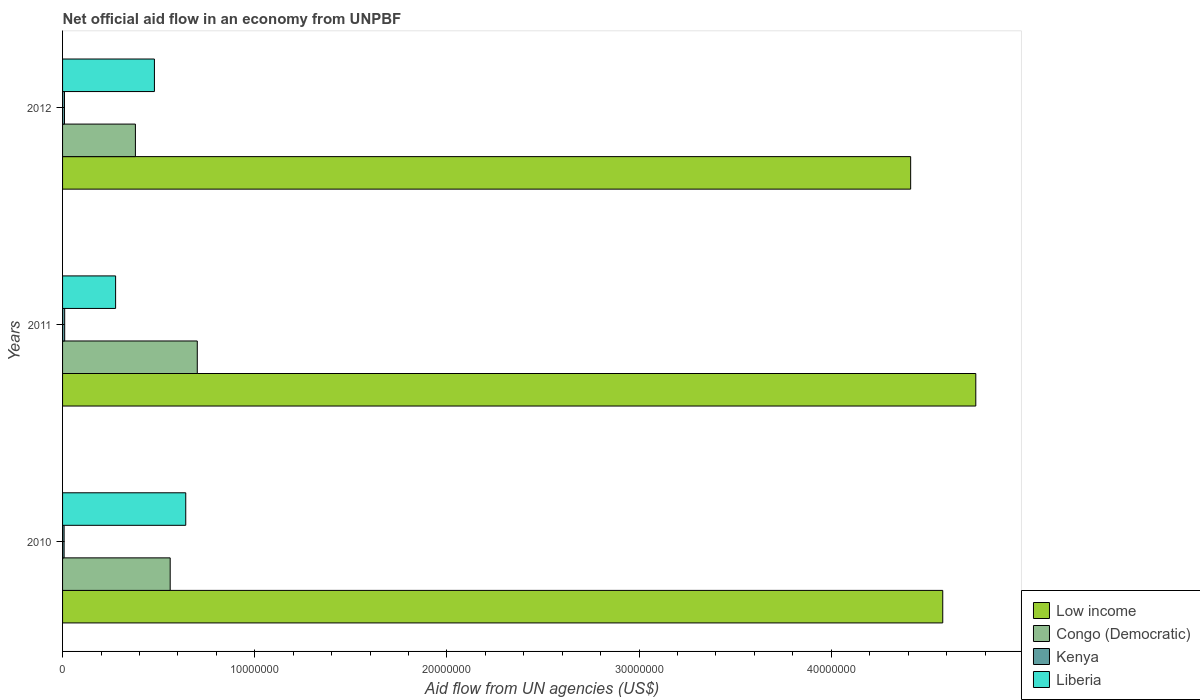How many groups of bars are there?
Offer a very short reply. 3. Are the number of bars per tick equal to the number of legend labels?
Keep it short and to the point. Yes. How many bars are there on the 1st tick from the top?
Offer a very short reply. 4. How many bars are there on the 1st tick from the bottom?
Give a very brief answer. 4. In how many cases, is the number of bars for a given year not equal to the number of legend labels?
Make the answer very short. 0. What is the net official aid flow in Kenya in 2010?
Make the answer very short. 8.00e+04. Across all years, what is the maximum net official aid flow in Congo (Democratic)?
Make the answer very short. 7.01e+06. Across all years, what is the minimum net official aid flow in Liberia?
Keep it short and to the point. 2.76e+06. In which year was the net official aid flow in Kenya maximum?
Your response must be concise. 2011. What is the total net official aid flow in Low income in the graph?
Make the answer very short. 1.37e+08. What is the difference between the net official aid flow in Liberia in 2011 and the net official aid flow in Congo (Democratic) in 2012?
Offer a terse response. -1.03e+06. What is the average net official aid flow in Kenya per year?
Your response must be concise. 9.67e+04. In the year 2010, what is the difference between the net official aid flow in Low income and net official aid flow in Congo (Democratic)?
Give a very brief answer. 4.02e+07. What is the ratio of the net official aid flow in Low income in 2011 to that in 2012?
Your response must be concise. 1.08. Is the difference between the net official aid flow in Low income in 2011 and 2012 greater than the difference between the net official aid flow in Congo (Democratic) in 2011 and 2012?
Ensure brevity in your answer.  Yes. What is the difference between the highest and the second highest net official aid flow in Low income?
Your answer should be compact. 1.72e+06. What is the difference between the highest and the lowest net official aid flow in Liberia?
Ensure brevity in your answer.  3.65e+06. In how many years, is the net official aid flow in Low income greater than the average net official aid flow in Low income taken over all years?
Provide a succinct answer. 1. Is it the case that in every year, the sum of the net official aid flow in Congo (Democratic) and net official aid flow in Liberia is greater than the sum of net official aid flow in Kenya and net official aid flow in Low income?
Your answer should be very brief. No. What does the 2nd bar from the top in 2010 represents?
Make the answer very short. Kenya. Are all the bars in the graph horizontal?
Provide a short and direct response. Yes. How many years are there in the graph?
Give a very brief answer. 3. What is the difference between two consecutive major ticks on the X-axis?
Make the answer very short. 1.00e+07. Are the values on the major ticks of X-axis written in scientific E-notation?
Give a very brief answer. No. Where does the legend appear in the graph?
Offer a very short reply. Bottom right. What is the title of the graph?
Give a very brief answer. Net official aid flow in an economy from UNPBF. Does "Russian Federation" appear as one of the legend labels in the graph?
Your answer should be compact. No. What is the label or title of the X-axis?
Your answer should be compact. Aid flow from UN agencies (US$). What is the label or title of the Y-axis?
Offer a terse response. Years. What is the Aid flow from UN agencies (US$) in Low income in 2010?
Provide a succinct answer. 4.58e+07. What is the Aid flow from UN agencies (US$) of Congo (Democratic) in 2010?
Your answer should be very brief. 5.60e+06. What is the Aid flow from UN agencies (US$) in Liberia in 2010?
Provide a succinct answer. 6.41e+06. What is the Aid flow from UN agencies (US$) of Low income in 2011?
Keep it short and to the point. 4.75e+07. What is the Aid flow from UN agencies (US$) in Congo (Democratic) in 2011?
Ensure brevity in your answer.  7.01e+06. What is the Aid flow from UN agencies (US$) of Kenya in 2011?
Keep it short and to the point. 1.10e+05. What is the Aid flow from UN agencies (US$) of Liberia in 2011?
Your answer should be very brief. 2.76e+06. What is the Aid flow from UN agencies (US$) in Low income in 2012?
Ensure brevity in your answer.  4.41e+07. What is the Aid flow from UN agencies (US$) in Congo (Democratic) in 2012?
Offer a terse response. 3.79e+06. What is the Aid flow from UN agencies (US$) of Liberia in 2012?
Offer a terse response. 4.78e+06. Across all years, what is the maximum Aid flow from UN agencies (US$) in Low income?
Provide a short and direct response. 4.75e+07. Across all years, what is the maximum Aid flow from UN agencies (US$) of Congo (Democratic)?
Give a very brief answer. 7.01e+06. Across all years, what is the maximum Aid flow from UN agencies (US$) of Liberia?
Your answer should be very brief. 6.41e+06. Across all years, what is the minimum Aid flow from UN agencies (US$) of Low income?
Your response must be concise. 4.41e+07. Across all years, what is the minimum Aid flow from UN agencies (US$) in Congo (Democratic)?
Provide a short and direct response. 3.79e+06. Across all years, what is the minimum Aid flow from UN agencies (US$) in Liberia?
Provide a succinct answer. 2.76e+06. What is the total Aid flow from UN agencies (US$) of Low income in the graph?
Your answer should be compact. 1.37e+08. What is the total Aid flow from UN agencies (US$) in Congo (Democratic) in the graph?
Provide a short and direct response. 1.64e+07. What is the total Aid flow from UN agencies (US$) of Kenya in the graph?
Your response must be concise. 2.90e+05. What is the total Aid flow from UN agencies (US$) in Liberia in the graph?
Keep it short and to the point. 1.40e+07. What is the difference between the Aid flow from UN agencies (US$) in Low income in 2010 and that in 2011?
Offer a very short reply. -1.72e+06. What is the difference between the Aid flow from UN agencies (US$) in Congo (Democratic) in 2010 and that in 2011?
Provide a short and direct response. -1.41e+06. What is the difference between the Aid flow from UN agencies (US$) in Kenya in 2010 and that in 2011?
Make the answer very short. -3.00e+04. What is the difference between the Aid flow from UN agencies (US$) in Liberia in 2010 and that in 2011?
Offer a terse response. 3.65e+06. What is the difference between the Aid flow from UN agencies (US$) in Low income in 2010 and that in 2012?
Your answer should be compact. 1.67e+06. What is the difference between the Aid flow from UN agencies (US$) in Congo (Democratic) in 2010 and that in 2012?
Keep it short and to the point. 1.81e+06. What is the difference between the Aid flow from UN agencies (US$) in Kenya in 2010 and that in 2012?
Provide a short and direct response. -2.00e+04. What is the difference between the Aid flow from UN agencies (US$) in Liberia in 2010 and that in 2012?
Your answer should be very brief. 1.63e+06. What is the difference between the Aid flow from UN agencies (US$) in Low income in 2011 and that in 2012?
Give a very brief answer. 3.39e+06. What is the difference between the Aid flow from UN agencies (US$) in Congo (Democratic) in 2011 and that in 2012?
Give a very brief answer. 3.22e+06. What is the difference between the Aid flow from UN agencies (US$) of Kenya in 2011 and that in 2012?
Ensure brevity in your answer.  10000. What is the difference between the Aid flow from UN agencies (US$) of Liberia in 2011 and that in 2012?
Your answer should be compact. -2.02e+06. What is the difference between the Aid flow from UN agencies (US$) in Low income in 2010 and the Aid flow from UN agencies (US$) in Congo (Democratic) in 2011?
Keep it short and to the point. 3.88e+07. What is the difference between the Aid flow from UN agencies (US$) in Low income in 2010 and the Aid flow from UN agencies (US$) in Kenya in 2011?
Provide a succinct answer. 4.57e+07. What is the difference between the Aid flow from UN agencies (US$) of Low income in 2010 and the Aid flow from UN agencies (US$) of Liberia in 2011?
Offer a terse response. 4.30e+07. What is the difference between the Aid flow from UN agencies (US$) in Congo (Democratic) in 2010 and the Aid flow from UN agencies (US$) in Kenya in 2011?
Your answer should be compact. 5.49e+06. What is the difference between the Aid flow from UN agencies (US$) in Congo (Democratic) in 2010 and the Aid flow from UN agencies (US$) in Liberia in 2011?
Ensure brevity in your answer.  2.84e+06. What is the difference between the Aid flow from UN agencies (US$) in Kenya in 2010 and the Aid flow from UN agencies (US$) in Liberia in 2011?
Your answer should be very brief. -2.68e+06. What is the difference between the Aid flow from UN agencies (US$) in Low income in 2010 and the Aid flow from UN agencies (US$) in Congo (Democratic) in 2012?
Provide a succinct answer. 4.20e+07. What is the difference between the Aid flow from UN agencies (US$) in Low income in 2010 and the Aid flow from UN agencies (US$) in Kenya in 2012?
Keep it short and to the point. 4.57e+07. What is the difference between the Aid flow from UN agencies (US$) of Low income in 2010 and the Aid flow from UN agencies (US$) of Liberia in 2012?
Your answer should be very brief. 4.10e+07. What is the difference between the Aid flow from UN agencies (US$) of Congo (Democratic) in 2010 and the Aid flow from UN agencies (US$) of Kenya in 2012?
Your answer should be compact. 5.50e+06. What is the difference between the Aid flow from UN agencies (US$) of Congo (Democratic) in 2010 and the Aid flow from UN agencies (US$) of Liberia in 2012?
Offer a very short reply. 8.20e+05. What is the difference between the Aid flow from UN agencies (US$) of Kenya in 2010 and the Aid flow from UN agencies (US$) of Liberia in 2012?
Give a very brief answer. -4.70e+06. What is the difference between the Aid flow from UN agencies (US$) of Low income in 2011 and the Aid flow from UN agencies (US$) of Congo (Democratic) in 2012?
Your answer should be compact. 4.37e+07. What is the difference between the Aid flow from UN agencies (US$) in Low income in 2011 and the Aid flow from UN agencies (US$) in Kenya in 2012?
Provide a short and direct response. 4.74e+07. What is the difference between the Aid flow from UN agencies (US$) in Low income in 2011 and the Aid flow from UN agencies (US$) in Liberia in 2012?
Provide a short and direct response. 4.27e+07. What is the difference between the Aid flow from UN agencies (US$) in Congo (Democratic) in 2011 and the Aid flow from UN agencies (US$) in Kenya in 2012?
Provide a succinct answer. 6.91e+06. What is the difference between the Aid flow from UN agencies (US$) of Congo (Democratic) in 2011 and the Aid flow from UN agencies (US$) of Liberia in 2012?
Your answer should be compact. 2.23e+06. What is the difference between the Aid flow from UN agencies (US$) in Kenya in 2011 and the Aid flow from UN agencies (US$) in Liberia in 2012?
Offer a very short reply. -4.67e+06. What is the average Aid flow from UN agencies (US$) in Low income per year?
Your response must be concise. 4.58e+07. What is the average Aid flow from UN agencies (US$) in Congo (Democratic) per year?
Provide a succinct answer. 5.47e+06. What is the average Aid flow from UN agencies (US$) in Kenya per year?
Make the answer very short. 9.67e+04. What is the average Aid flow from UN agencies (US$) in Liberia per year?
Provide a short and direct response. 4.65e+06. In the year 2010, what is the difference between the Aid flow from UN agencies (US$) of Low income and Aid flow from UN agencies (US$) of Congo (Democratic)?
Offer a very short reply. 4.02e+07. In the year 2010, what is the difference between the Aid flow from UN agencies (US$) in Low income and Aid flow from UN agencies (US$) in Kenya?
Make the answer very short. 4.57e+07. In the year 2010, what is the difference between the Aid flow from UN agencies (US$) of Low income and Aid flow from UN agencies (US$) of Liberia?
Provide a short and direct response. 3.94e+07. In the year 2010, what is the difference between the Aid flow from UN agencies (US$) in Congo (Democratic) and Aid flow from UN agencies (US$) in Kenya?
Make the answer very short. 5.52e+06. In the year 2010, what is the difference between the Aid flow from UN agencies (US$) in Congo (Democratic) and Aid flow from UN agencies (US$) in Liberia?
Your answer should be compact. -8.10e+05. In the year 2010, what is the difference between the Aid flow from UN agencies (US$) in Kenya and Aid flow from UN agencies (US$) in Liberia?
Your answer should be compact. -6.33e+06. In the year 2011, what is the difference between the Aid flow from UN agencies (US$) of Low income and Aid flow from UN agencies (US$) of Congo (Democratic)?
Your response must be concise. 4.05e+07. In the year 2011, what is the difference between the Aid flow from UN agencies (US$) in Low income and Aid flow from UN agencies (US$) in Kenya?
Offer a terse response. 4.74e+07. In the year 2011, what is the difference between the Aid flow from UN agencies (US$) of Low income and Aid flow from UN agencies (US$) of Liberia?
Provide a short and direct response. 4.48e+07. In the year 2011, what is the difference between the Aid flow from UN agencies (US$) of Congo (Democratic) and Aid flow from UN agencies (US$) of Kenya?
Your response must be concise. 6.90e+06. In the year 2011, what is the difference between the Aid flow from UN agencies (US$) of Congo (Democratic) and Aid flow from UN agencies (US$) of Liberia?
Ensure brevity in your answer.  4.25e+06. In the year 2011, what is the difference between the Aid flow from UN agencies (US$) of Kenya and Aid flow from UN agencies (US$) of Liberia?
Offer a very short reply. -2.65e+06. In the year 2012, what is the difference between the Aid flow from UN agencies (US$) of Low income and Aid flow from UN agencies (US$) of Congo (Democratic)?
Offer a very short reply. 4.03e+07. In the year 2012, what is the difference between the Aid flow from UN agencies (US$) in Low income and Aid flow from UN agencies (US$) in Kenya?
Keep it short and to the point. 4.40e+07. In the year 2012, what is the difference between the Aid flow from UN agencies (US$) in Low income and Aid flow from UN agencies (US$) in Liberia?
Keep it short and to the point. 3.94e+07. In the year 2012, what is the difference between the Aid flow from UN agencies (US$) in Congo (Democratic) and Aid flow from UN agencies (US$) in Kenya?
Your answer should be very brief. 3.69e+06. In the year 2012, what is the difference between the Aid flow from UN agencies (US$) in Congo (Democratic) and Aid flow from UN agencies (US$) in Liberia?
Ensure brevity in your answer.  -9.90e+05. In the year 2012, what is the difference between the Aid flow from UN agencies (US$) of Kenya and Aid flow from UN agencies (US$) of Liberia?
Your response must be concise. -4.68e+06. What is the ratio of the Aid flow from UN agencies (US$) in Low income in 2010 to that in 2011?
Your answer should be very brief. 0.96. What is the ratio of the Aid flow from UN agencies (US$) in Congo (Democratic) in 2010 to that in 2011?
Provide a short and direct response. 0.8. What is the ratio of the Aid flow from UN agencies (US$) in Kenya in 2010 to that in 2011?
Give a very brief answer. 0.73. What is the ratio of the Aid flow from UN agencies (US$) in Liberia in 2010 to that in 2011?
Offer a very short reply. 2.32. What is the ratio of the Aid flow from UN agencies (US$) of Low income in 2010 to that in 2012?
Provide a short and direct response. 1.04. What is the ratio of the Aid flow from UN agencies (US$) in Congo (Democratic) in 2010 to that in 2012?
Provide a short and direct response. 1.48. What is the ratio of the Aid flow from UN agencies (US$) in Kenya in 2010 to that in 2012?
Keep it short and to the point. 0.8. What is the ratio of the Aid flow from UN agencies (US$) in Liberia in 2010 to that in 2012?
Make the answer very short. 1.34. What is the ratio of the Aid flow from UN agencies (US$) in Low income in 2011 to that in 2012?
Offer a very short reply. 1.08. What is the ratio of the Aid flow from UN agencies (US$) of Congo (Democratic) in 2011 to that in 2012?
Your answer should be very brief. 1.85. What is the ratio of the Aid flow from UN agencies (US$) of Kenya in 2011 to that in 2012?
Offer a very short reply. 1.1. What is the ratio of the Aid flow from UN agencies (US$) in Liberia in 2011 to that in 2012?
Your response must be concise. 0.58. What is the difference between the highest and the second highest Aid flow from UN agencies (US$) of Low income?
Your answer should be very brief. 1.72e+06. What is the difference between the highest and the second highest Aid flow from UN agencies (US$) of Congo (Democratic)?
Make the answer very short. 1.41e+06. What is the difference between the highest and the second highest Aid flow from UN agencies (US$) of Liberia?
Provide a succinct answer. 1.63e+06. What is the difference between the highest and the lowest Aid flow from UN agencies (US$) of Low income?
Provide a short and direct response. 3.39e+06. What is the difference between the highest and the lowest Aid flow from UN agencies (US$) in Congo (Democratic)?
Your answer should be compact. 3.22e+06. What is the difference between the highest and the lowest Aid flow from UN agencies (US$) in Kenya?
Offer a terse response. 3.00e+04. What is the difference between the highest and the lowest Aid flow from UN agencies (US$) of Liberia?
Offer a very short reply. 3.65e+06. 